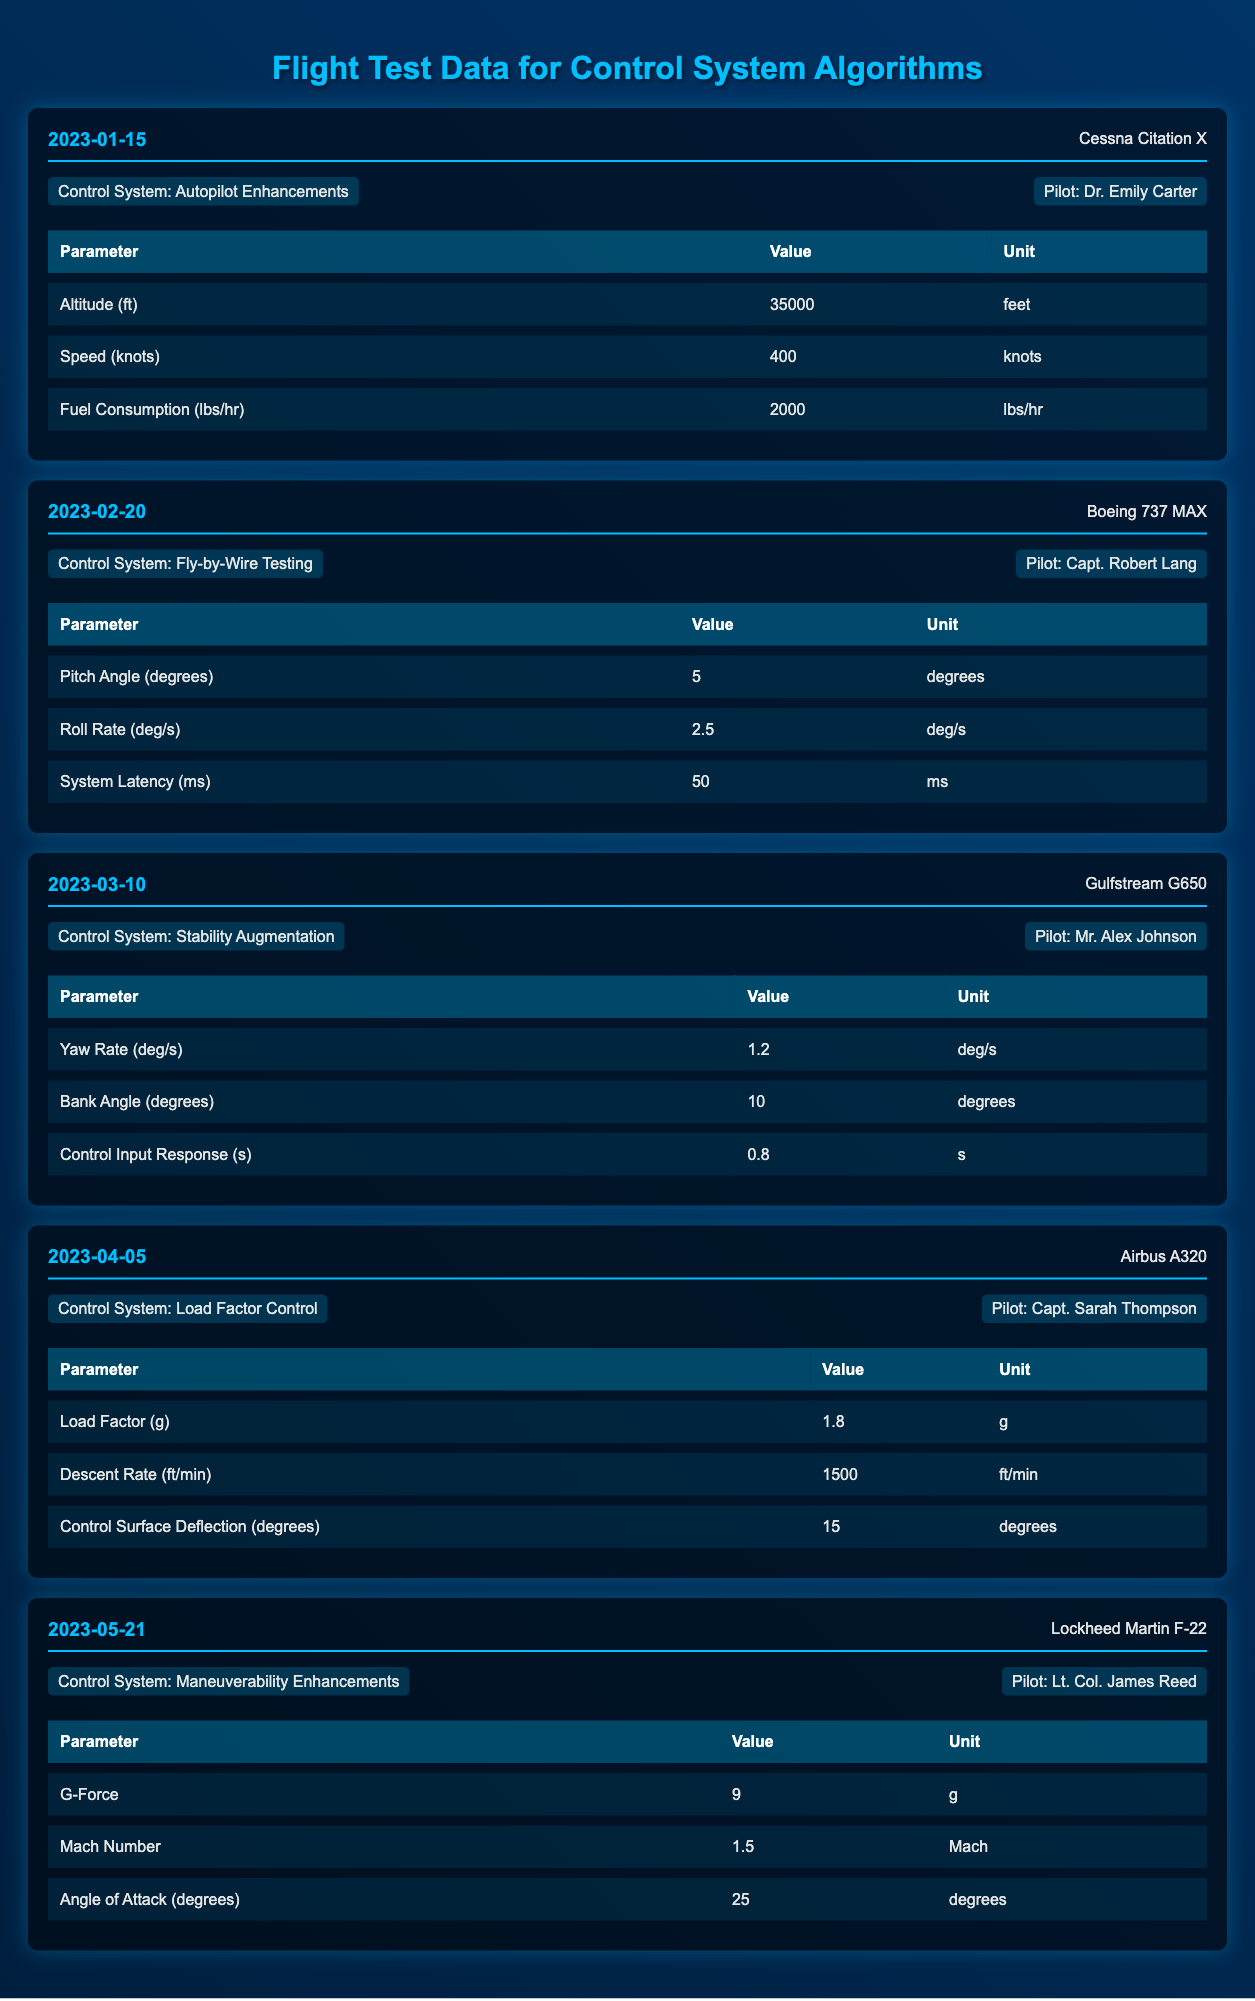What aircraft was used on the test flight date 2023-04-05? The table indicates that on April 5, 2023, the aircraft used was the Airbus A320. This is directly stated in the flight test header for that date.
Answer: Airbus A320 Who was the test pilot for the flight on 2023-02-20? According to the flight test information for February 20, 2023, the pilot was Capt. Robert Lang. This name is listed directly beneath the control system.
Answer: Capt. Robert Lang What was the speed recorded for the Cessna Citation X? The data point for speed under the Cessna Citation X indicates a recorded speed of 400 knots. This value is taken from the respective row in the data table for that aircraft.
Answer: 400 knots Is the G-Force recorded during the Lockheed Martin F-22 test flight greater than 8? The G-Force recorded for the Lockheed Martin F-22 is 9 g, which is indeed greater than 8. This can be verified by looking at the data point under the Lockheed Martin F-22 section.
Answer: Yes What is the average descent rate of the aircraft tested in April 2023? There is only one entry for April 5, 2023, where the descent rate is 1500 ft/min. Since there is no other data point for April, the average is simply that single value. The average descent rate is therefore 1500 ft/min.
Answer: 1500 ft/min What was the maximum recorded altitude during the tests? The maximum altitude can be found by reviewing all the altitude values provided in the table: 35000 feet (Cessna Citation X), with no data indicating altitudes above this. Since 35000 feet is the highest reported value, it is determined to be the maximum.
Answer: 35000 feet Which control system had the highest Mach number recorded? The data point for the Lockheed Martin F-22 lists a Mach number of 1.5, while none of the other aircraft recorded a Mach number. Thus, the Mach number for the F-22 is the highest value in the table.
Answer: 1.5 Mach What is the difference in pitch angle between the Boeing 737 MAX and the Gulfstream G650? For the Boeing 737 MAX, the pitch angle is 5 degrees, and for the Gulfstream G650, there is no pitch angle listed; therefore, we can only calculate the difference using the data available. Since the Gulfstream G650 does not have a pitch angle, this question cannot be answered with a clear numerical difference, leading us to conclude there is no value for comparison.
Answer: Not applicable Was the control system tested in the Gulfstream G650 focused on enhancing stability? Yes, the table indicates that the control system for the Gulfstream G650 was Stability Augmentation, meaning its purpose was indeed to enhance stability. This is clearly stated in the corresponding section of the table.
Answer: Yes 